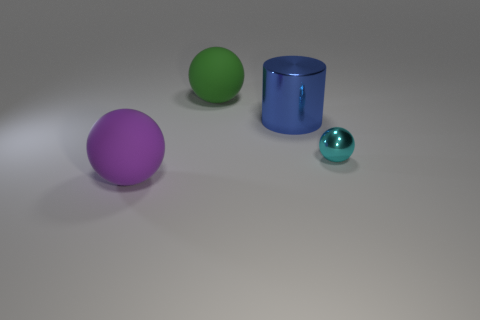The big ball that is made of the same material as the large green thing is what color? The big ball that shares its material with the large green object in the image is purple in color. Its smooth surface and uniform hue make it easily distinguishable from the other objects present. 